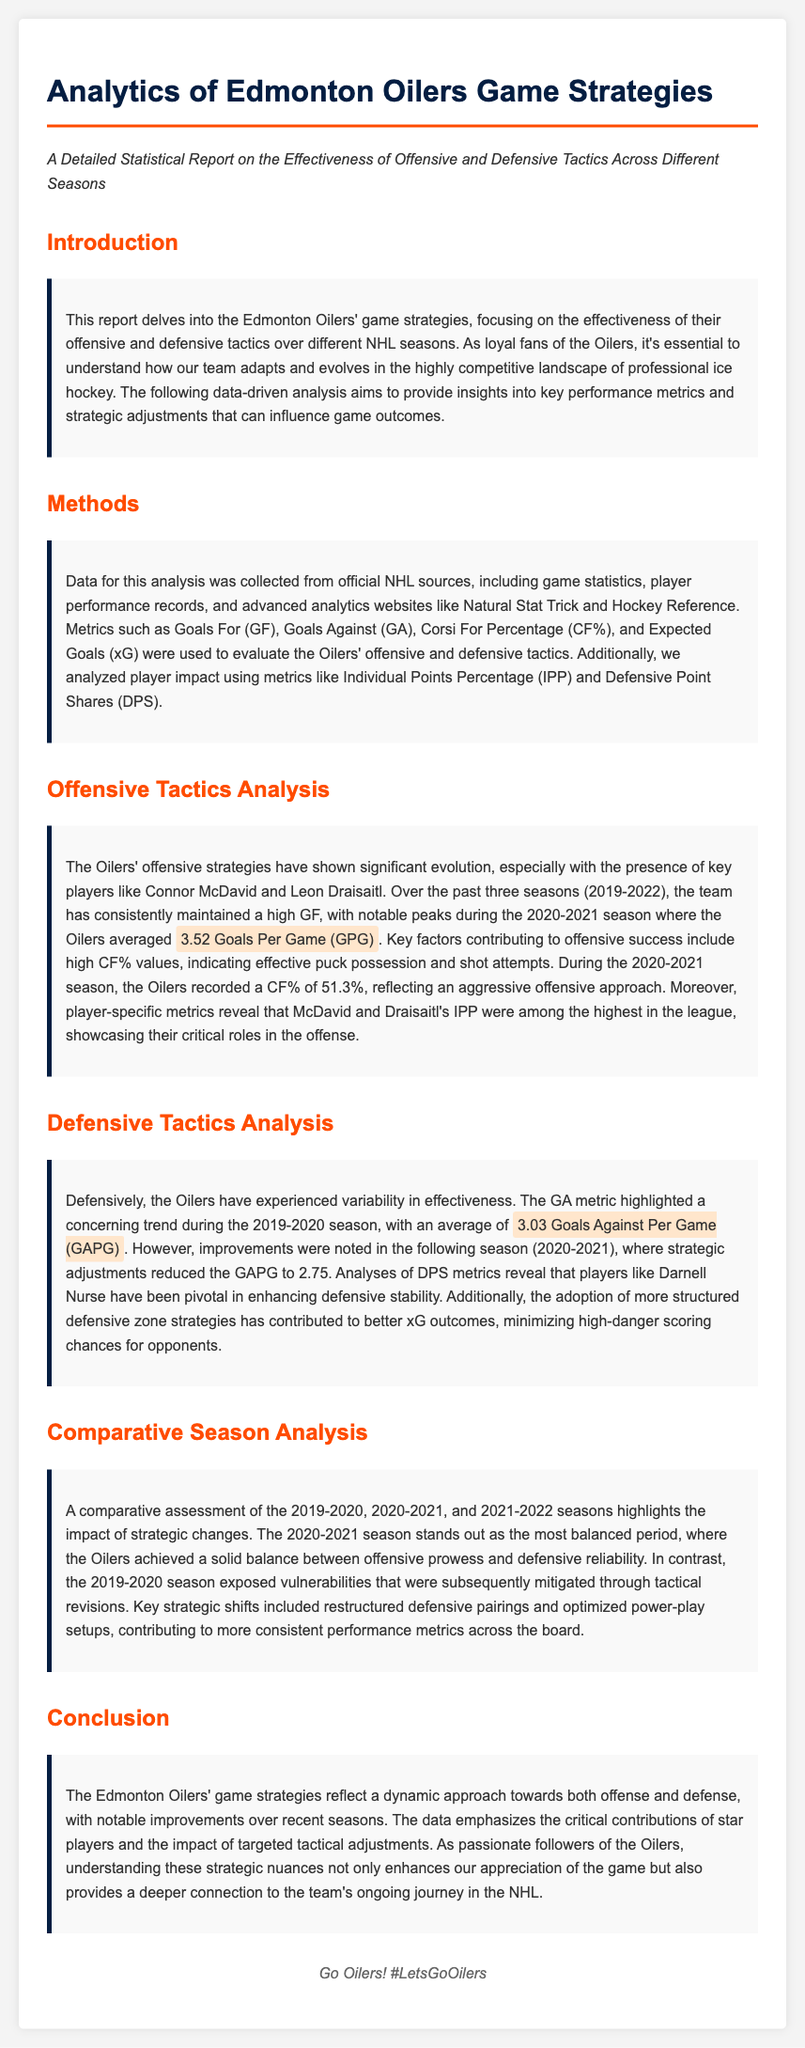What is the average Goals Per Game for the Oilers in the 2020-2021 season? The document states that during the 2020-2021 season, the Oilers averaged 3.52 Goals Per Game (GPG).
Answer: 3.52 Goals Per Game What metric showed variability in the Oilers' defensive effectiveness? The Goals Against (GA) metric highlighted a concerning trend during the 2019-2020 season, reflecting variability in defensive effectiveness.
Answer: Goals Against Who are two key players contributing to the Oilers' offense? The document mentions Connor McDavid and Leon Draisaitl as crucial contributors to the Oilers' offense.
Answer: Connor McDavid and Leon Draisaitl What was the Oilers' average Goals Against Per Game in the 2019-2020 season? The average Goals Against Per Game during the 2019-2020 season was 3.03.
Answer: 3.03 What season is described as the most balanced in terms of offensive and defensive strategies? The 2020-2021 season is noted as the most balanced period for the Oilers.
Answer: 2020-2021 season What statistical metric reflected an aggressive offensive approach in the 2020-2021 season? The Corsi For Percentage (CF%) indicated the effective puck possession and shot attempts, reflecting an aggressive offensive approach in the 2020-2021 season.
Answer: Corsi For Percentage Which player is highlighted for enhancing defensive stability? Darnell Nurse is noted as pivotal in enhancing defensive stability for the Oilers.
Answer: Darnell Nurse What strategic change was made to improve performance metrics? The document mentions restructured defensive pairings as a key strategic shift to improve performance metrics.
Answer: Restructured defensive pairings 